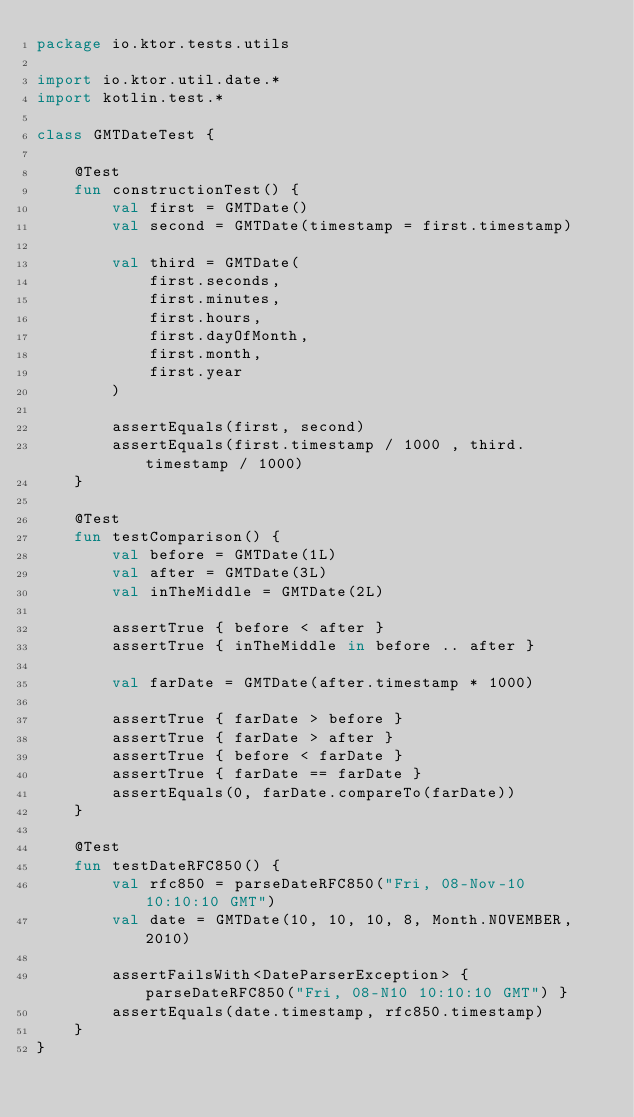<code> <loc_0><loc_0><loc_500><loc_500><_Kotlin_>package io.ktor.tests.utils

import io.ktor.util.date.*
import kotlin.test.*

class GMTDateTest {

    @Test
    fun constructionTest() {
        val first = GMTDate()
        val second = GMTDate(timestamp = first.timestamp)

        val third = GMTDate(
            first.seconds,
            first.minutes,
            first.hours,
            first.dayOfMonth,
            first.month,
            first.year
        )

        assertEquals(first, second)
        assertEquals(first.timestamp / 1000 , third.timestamp / 1000)
    }

    @Test
    fun testComparison() {
        val before = GMTDate(1L)
        val after = GMTDate(3L)
        val inTheMiddle = GMTDate(2L)

        assertTrue { before < after }
        assertTrue { inTheMiddle in before .. after }

        val farDate = GMTDate(after.timestamp * 1000)

        assertTrue { farDate > before }
        assertTrue { farDate > after }
        assertTrue { before < farDate }
        assertTrue { farDate == farDate }
        assertEquals(0, farDate.compareTo(farDate))
    }

    @Test
    fun testDateRFC850() {
        val rfc850 = parseDateRFC850("Fri, 08-Nov-10 10:10:10 GMT")
        val date = GMTDate(10, 10, 10, 8, Month.NOVEMBER, 2010)

        assertFailsWith<DateParserException> { parseDateRFC850("Fri, 08-N10 10:10:10 GMT") }
        assertEquals(date.timestamp, rfc850.timestamp)
    }
}
</code> 